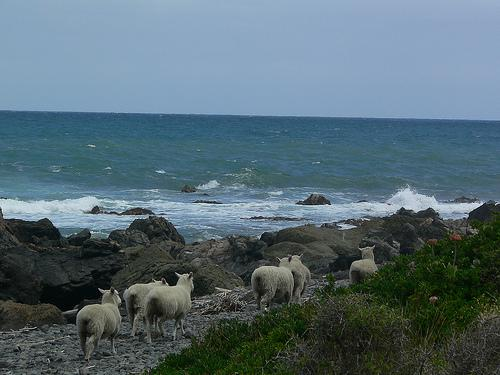Mention any outstanding feature of the waters in the image. Ocean waves are breaking on the rocks and covered with white sea foam. What type of interaction is happening between the sheep and the environment they are in? The sheep are walking on a stony path next to the ocean, and they're adapting to the rocky terrain, engaging with the natural surroundings. Considering the positions of the objects, can you speculate about the quality of the image? The image is likely to be high quality with crisp details, as numerous objects and their positions are well-defined, including the smaller elements like flowers and parts of sheep. Tell me about the dominant theme in the image. Sheep walking on a rocky path alongside the ocean, with green grass, blooming flowers, and rocks on the shore. What are some of the elements in the image that add a sense of calmness to the scene? Calm surface of water, clear blue cloudless sky above water, and green bushes growing along the shore. Please provide a detailed description of the vegetation in the image. There is green grass along a trail, flowers blooming, green brush on a hillside, green bushes growing on the shore, and green moss growing on top of a rock. What's happening with the group of three white sheep? The group of three white sheep are walking on a stony path near the ocean. Can you count the number of walking white sheep in the image? There are 6 walking white sheep in the image. Analyze the mood or sentiment of the image based on the elements present. The image displays a peaceful and serene atmosphere with sheep walking leisurely along the shore, and calm ocean waters against a clear blue sky. 